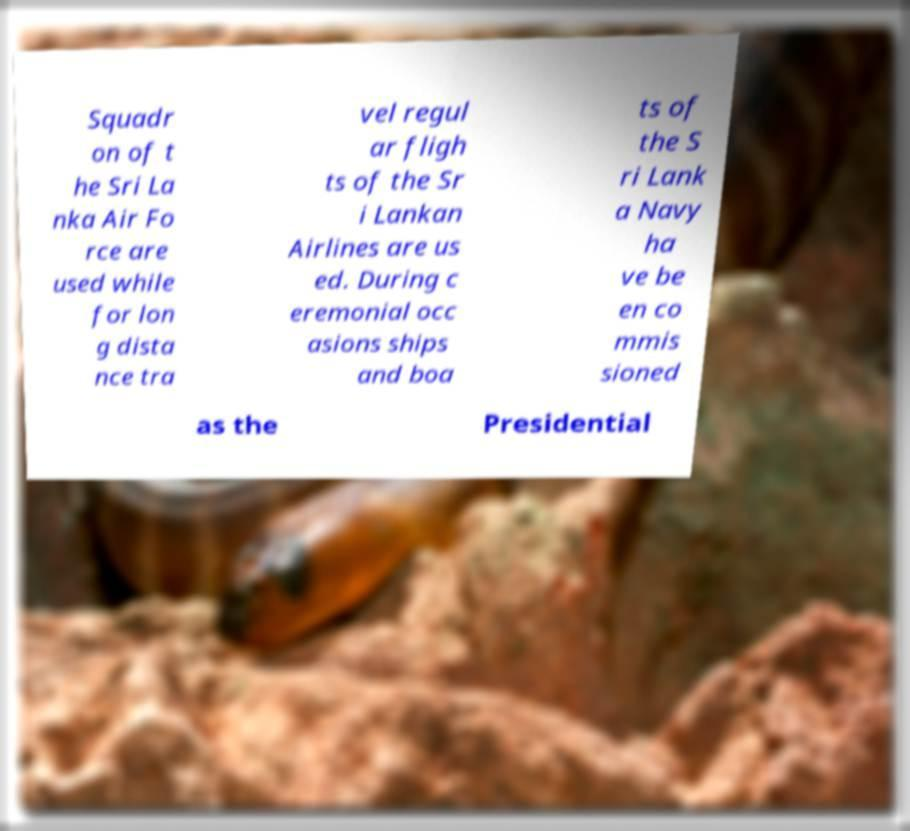There's text embedded in this image that I need extracted. Can you transcribe it verbatim? Squadr on of t he Sri La nka Air Fo rce are used while for lon g dista nce tra vel regul ar fligh ts of the Sr i Lankan Airlines are us ed. During c eremonial occ asions ships and boa ts of the S ri Lank a Navy ha ve be en co mmis sioned as the Presidential 